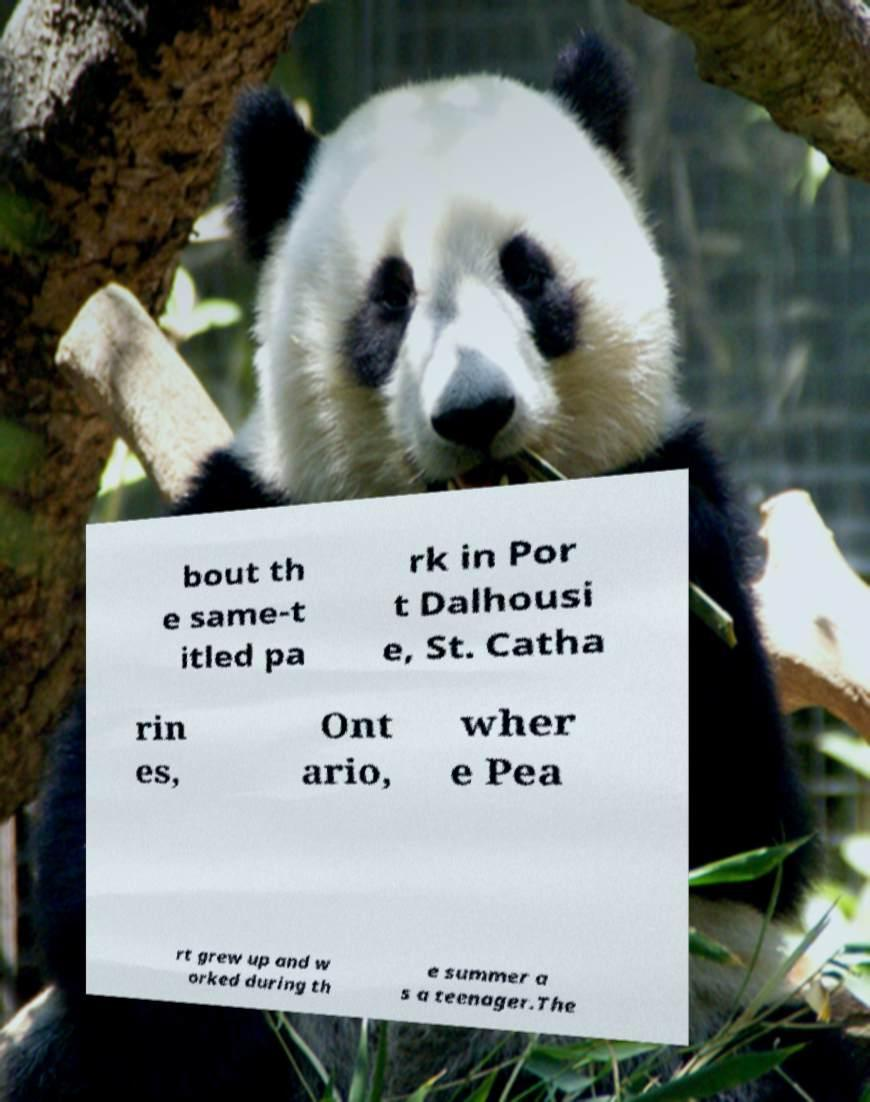There's text embedded in this image that I need extracted. Can you transcribe it verbatim? bout th e same-t itled pa rk in Por t Dalhousi e, St. Catha rin es, Ont ario, wher e Pea rt grew up and w orked during th e summer a s a teenager.The 